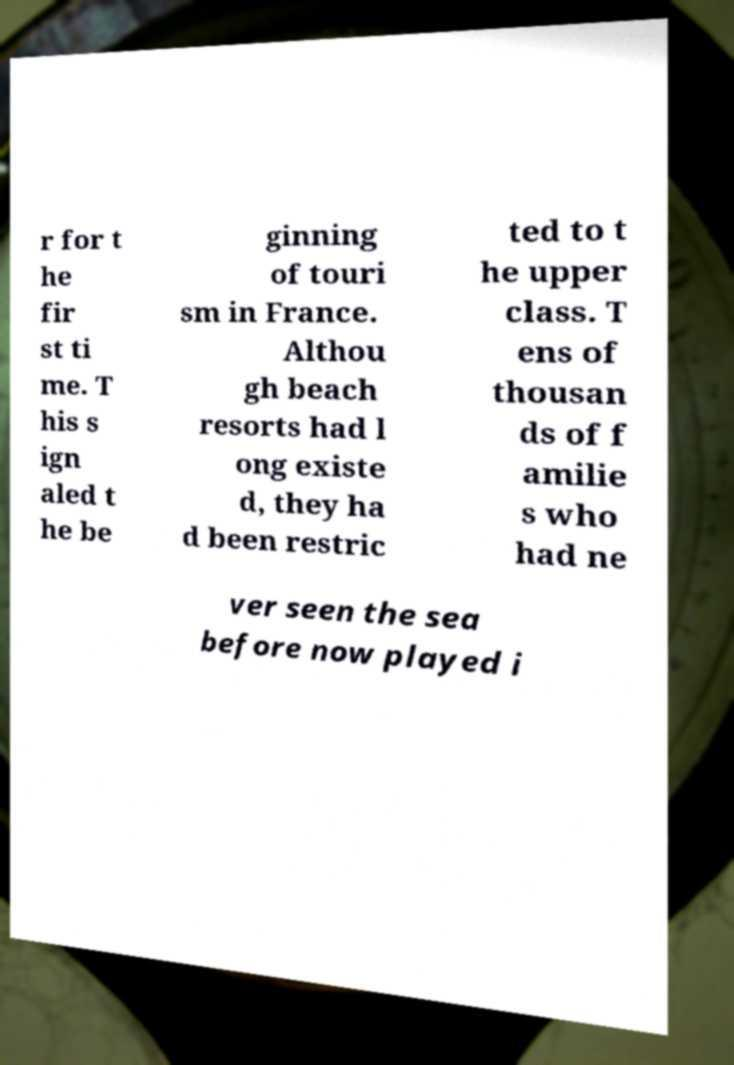Please read and relay the text visible in this image. What does it say? r for t he fir st ti me. T his s ign aled t he be ginning of touri sm in France. Althou gh beach resorts had l ong existe d, they ha d been restric ted to t he upper class. T ens of thousan ds of f amilie s who had ne ver seen the sea before now played i 